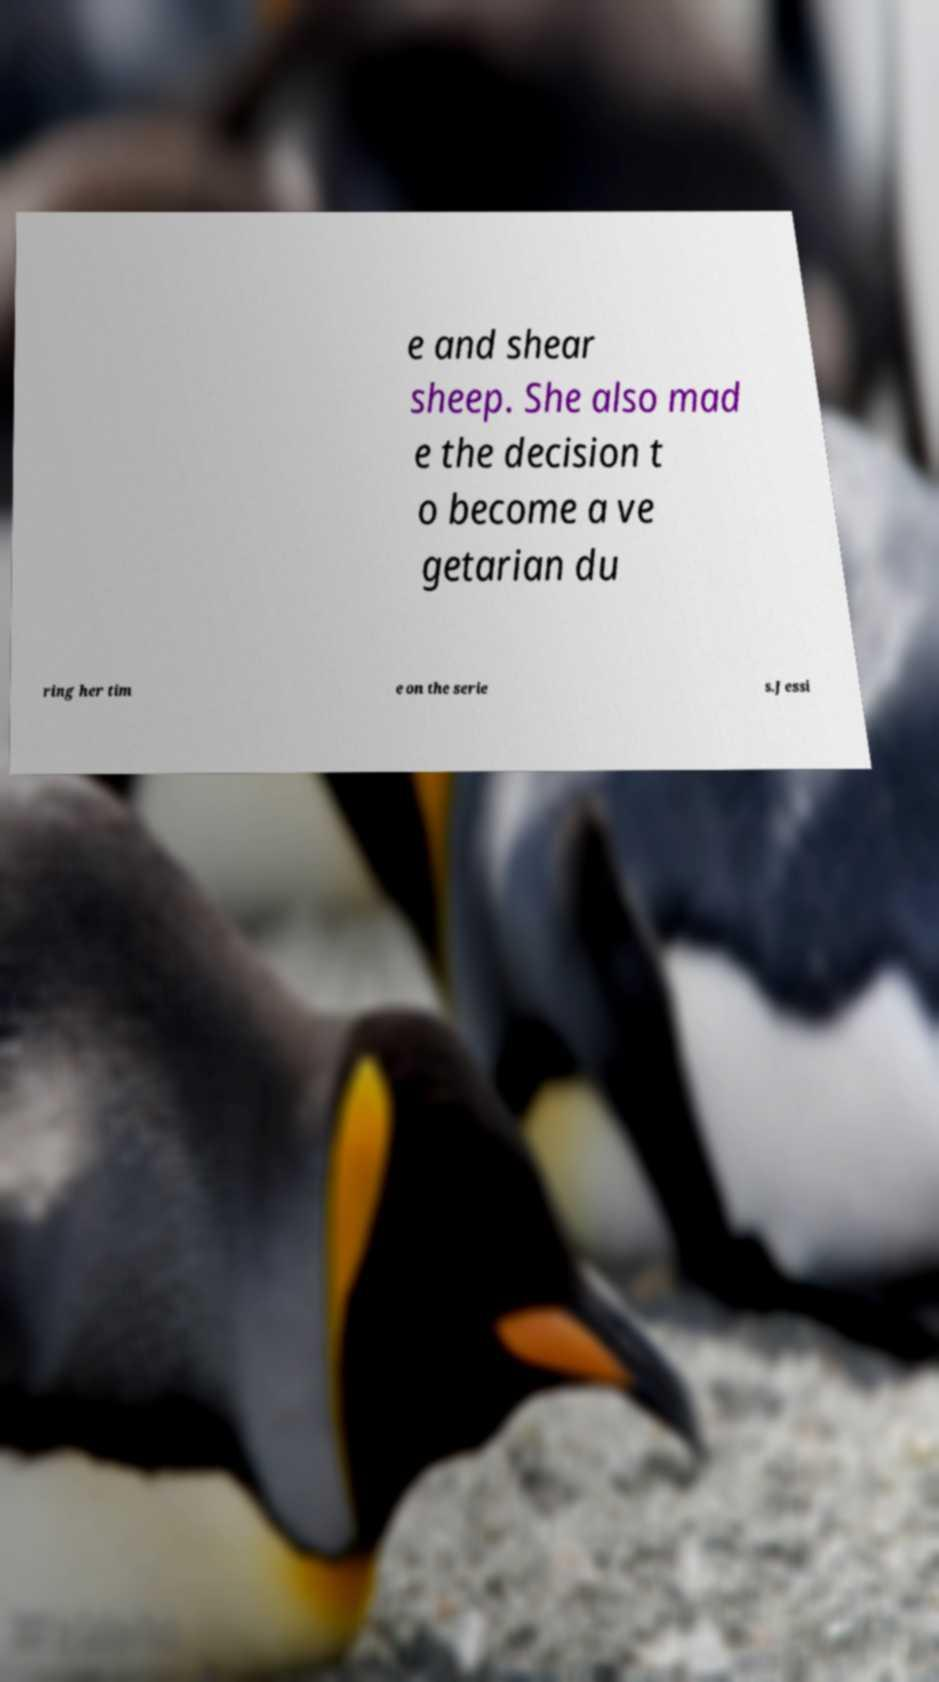Could you extract and type out the text from this image? e and shear sheep. She also mad e the decision t o become a ve getarian du ring her tim e on the serie s.Jessi 